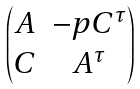Convert formula to latex. <formula><loc_0><loc_0><loc_500><loc_500>\begin{pmatrix} A & - p C ^ { \tau } \\ C & A ^ { \tau } \end{pmatrix}</formula> 